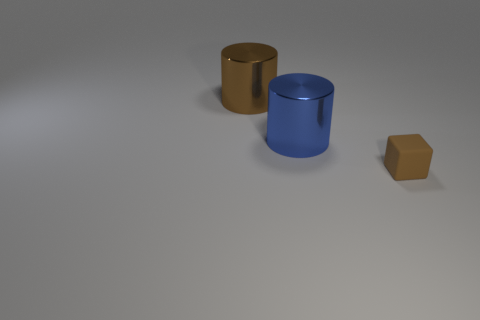Subtract all blocks. How many objects are left? 2 Subtract 1 blocks. How many blocks are left? 0 Add 2 brown metallic spheres. How many objects exist? 5 Subtract 1 blue cylinders. How many objects are left? 2 Subtract all cyan cylinders. Subtract all blue spheres. How many cylinders are left? 2 Subtract all cyan cubes. How many blue cylinders are left? 1 Subtract all tiny cubes. Subtract all red metallic blocks. How many objects are left? 2 Add 1 large blue cylinders. How many large blue cylinders are left? 2 Add 3 big blue metallic cylinders. How many big blue metallic cylinders exist? 4 